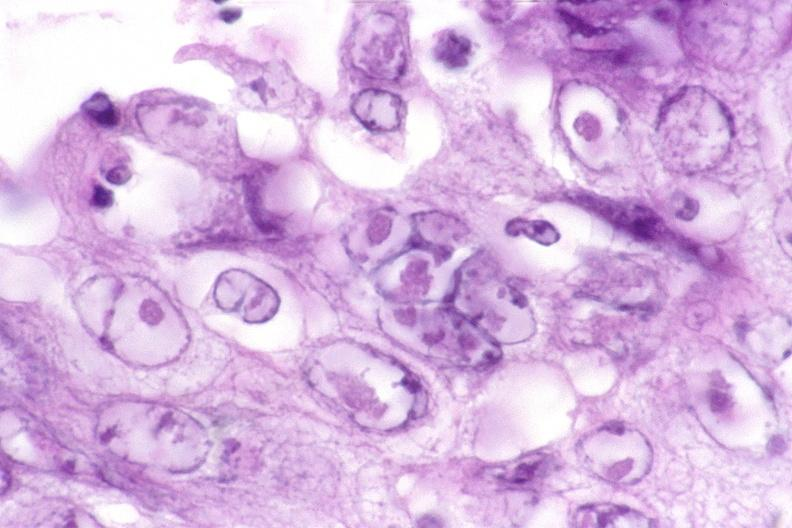what does this image show?
Answer the question using a single word or phrase. Esophagus 